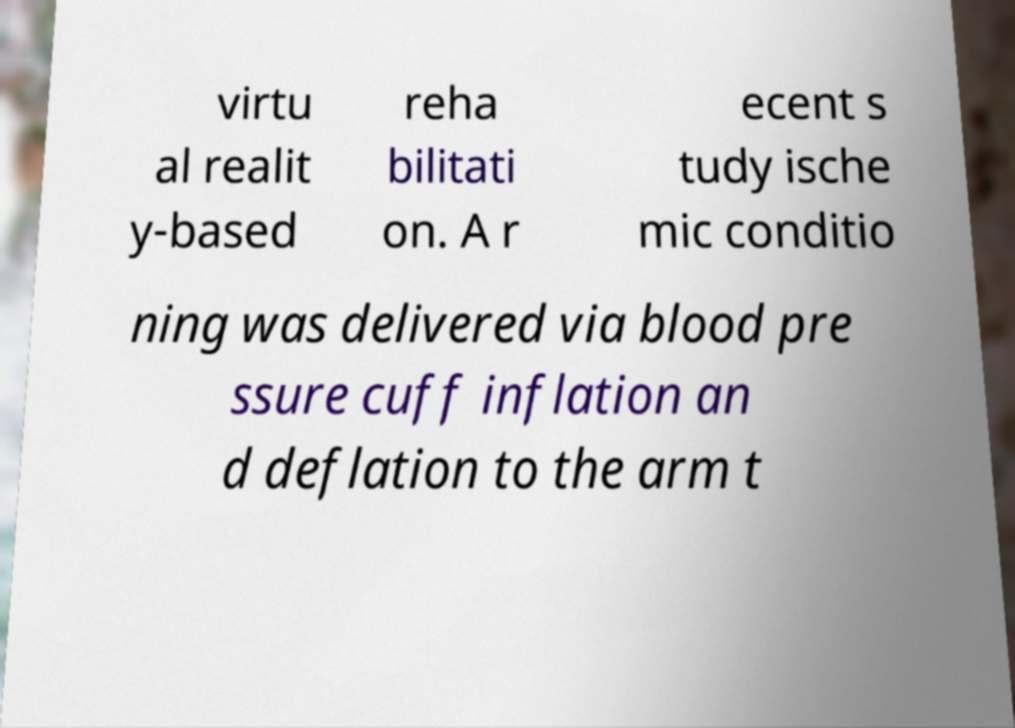Can you read and provide the text displayed in the image?This photo seems to have some interesting text. Can you extract and type it out for me? virtu al realit y-based reha bilitati on. A r ecent s tudy ische mic conditio ning was delivered via blood pre ssure cuff inflation an d deflation to the arm t 